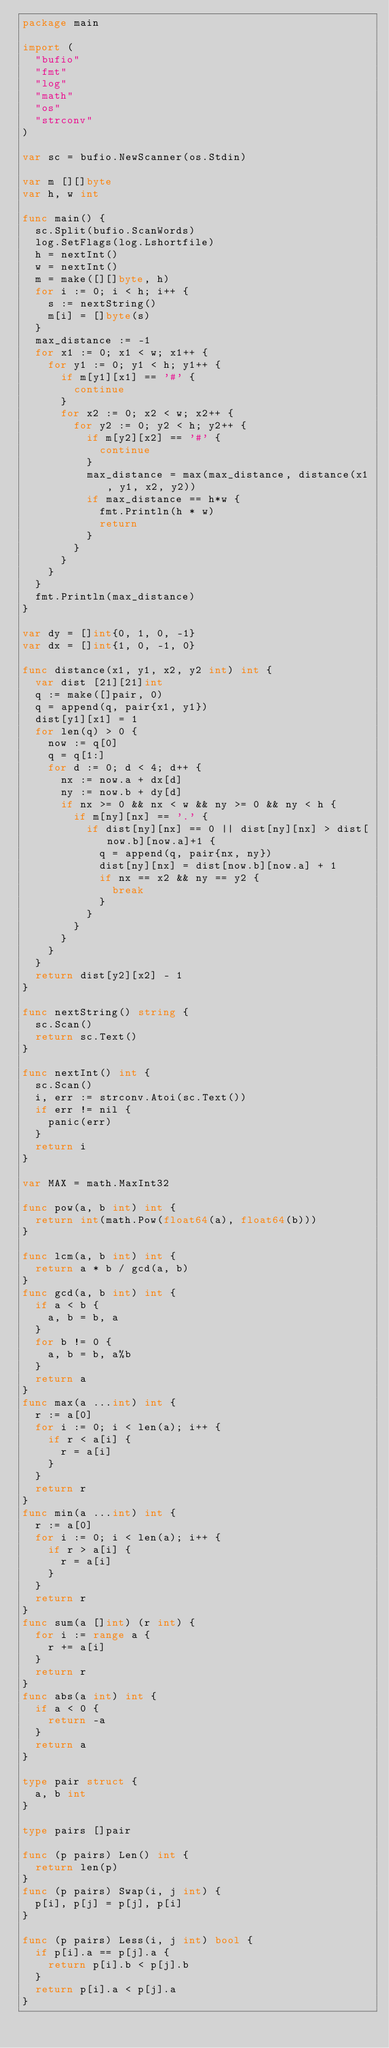Convert code to text. <code><loc_0><loc_0><loc_500><loc_500><_Go_>package main

import (
	"bufio"
	"fmt"
	"log"
	"math"
	"os"
	"strconv"
)

var sc = bufio.NewScanner(os.Stdin)

var m [][]byte
var h, w int

func main() {
	sc.Split(bufio.ScanWords)
	log.SetFlags(log.Lshortfile)
	h = nextInt()
	w = nextInt()
	m = make([][]byte, h)
	for i := 0; i < h; i++ {
		s := nextString()
		m[i] = []byte(s)
	}
	max_distance := -1
	for x1 := 0; x1 < w; x1++ {
		for y1 := 0; y1 < h; y1++ {
			if m[y1][x1] == '#' {
				continue
			}
			for x2 := 0; x2 < w; x2++ {
				for y2 := 0; y2 < h; y2++ {
					if m[y2][x2] == '#' {
						continue
					}
					max_distance = max(max_distance, distance(x1, y1, x2, y2))
					if max_distance == h*w {
						fmt.Println(h * w)
						return
					}
				}
			}
		}
	}
	fmt.Println(max_distance)
}

var dy = []int{0, 1, 0, -1}
var dx = []int{1, 0, -1, 0}

func distance(x1, y1, x2, y2 int) int {
	var dist [21][21]int
	q := make([]pair, 0)
	q = append(q, pair{x1, y1})
	dist[y1][x1] = 1
	for len(q) > 0 {
		now := q[0]
		q = q[1:]
		for d := 0; d < 4; d++ {
			nx := now.a + dx[d]
			ny := now.b + dy[d]
			if nx >= 0 && nx < w && ny >= 0 && ny < h {
				if m[ny][nx] == '.' {
					if dist[ny][nx] == 0 || dist[ny][nx] > dist[now.b][now.a]+1 {
						q = append(q, pair{nx, ny})
						dist[ny][nx] = dist[now.b][now.a] + 1
						if nx == x2 && ny == y2 {
							break
						}
					}
				}
			}
		}
	}
	return dist[y2][x2] - 1
}

func nextString() string {
	sc.Scan()
	return sc.Text()
}

func nextInt() int {
	sc.Scan()
	i, err := strconv.Atoi(sc.Text())
	if err != nil {
		panic(err)
	}
	return i
}

var MAX = math.MaxInt32

func pow(a, b int) int {
	return int(math.Pow(float64(a), float64(b)))
}

func lcm(a, b int) int {
	return a * b / gcd(a, b)
}
func gcd(a, b int) int {
	if a < b {
		a, b = b, a
	}
	for b != 0 {
		a, b = b, a%b
	}
	return a
}
func max(a ...int) int {
	r := a[0]
	for i := 0; i < len(a); i++ {
		if r < a[i] {
			r = a[i]
		}
	}
	return r
}
func min(a ...int) int {
	r := a[0]
	for i := 0; i < len(a); i++ {
		if r > a[i] {
			r = a[i]
		}
	}
	return r
}
func sum(a []int) (r int) {
	for i := range a {
		r += a[i]
	}
	return r
}
func abs(a int) int {
	if a < 0 {
		return -a
	}
	return a
}

type pair struct {
	a, b int
}

type pairs []pair

func (p pairs) Len() int {
	return len(p)
}
func (p pairs) Swap(i, j int) {
	p[i], p[j] = p[j], p[i]
}

func (p pairs) Less(i, j int) bool {
	if p[i].a == p[j].a {
		return p[i].b < p[j].b
	}
	return p[i].a < p[j].a
}
</code> 